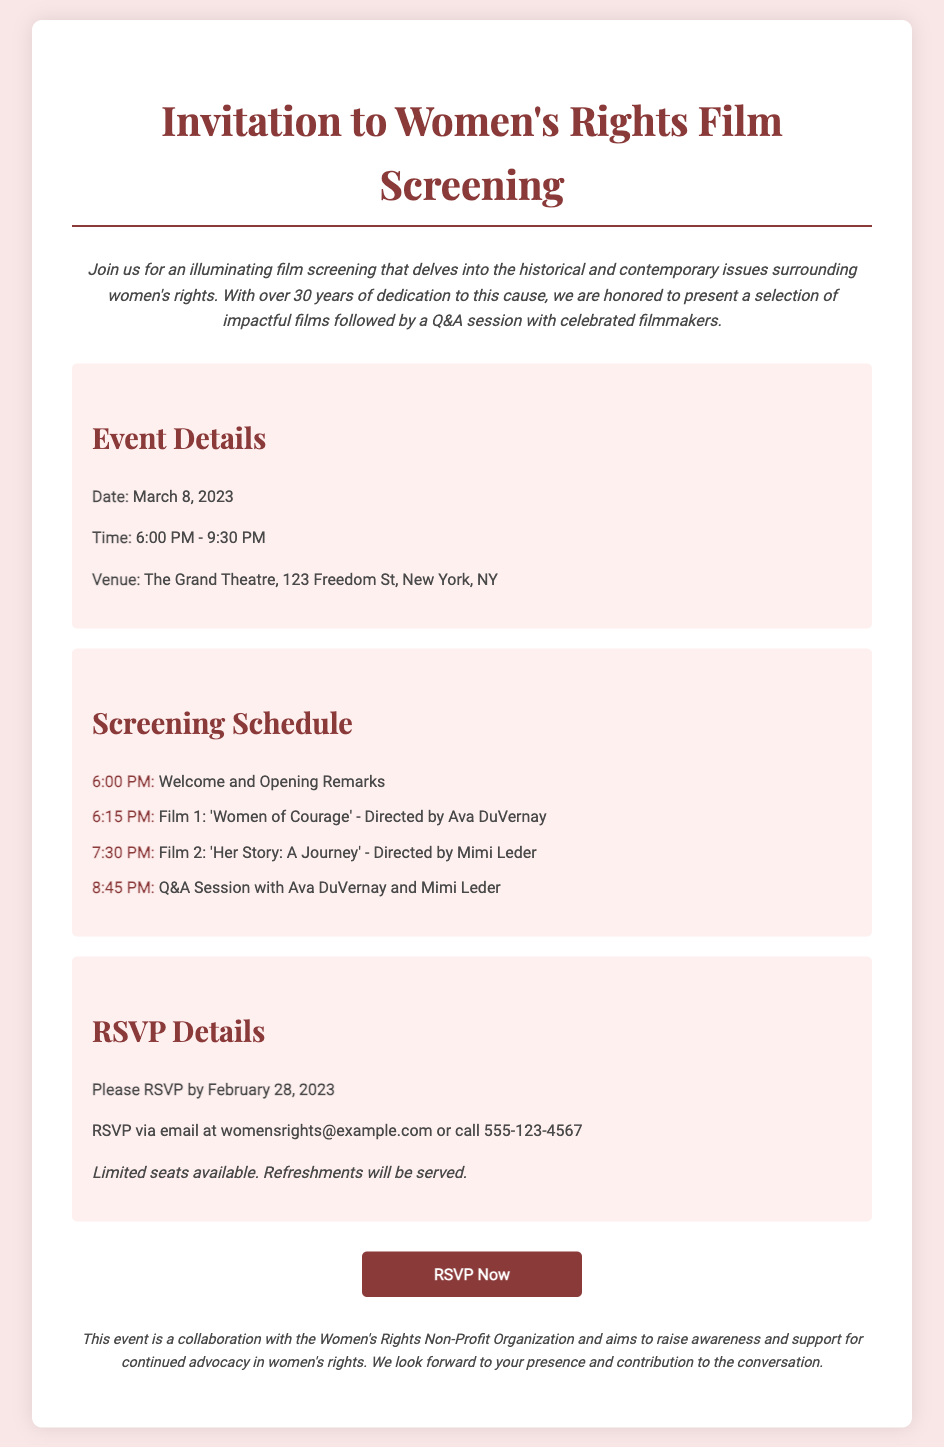What is the date of the event? The date of the event is directly stated in the document under Event Details.
Answer: March 8, 2023 What time does the screening start? The start time is mentioned in the document as part of the Event Details section.
Answer: 6:00 PM Who directed the first film? The director of the first film is specifically mentioned in the Screening Schedule section.
Answer: Ava DuVernay What is the venue name? The venue name is provided in the Event Details section.
Answer: The Grand Theatre How long is the Q&A session scheduled to last? The Q&A session follows the screenings, and its timing can be determined by the schedule provided.
Answer: 15 minutes What is the RSVP deadline? The RSVP deadline is explicitly stated in the RSVP Details paragraph.
Answer: February 28, 2023 How can attendees RSVP? The RSVP methods are detailed in the RSVP Details section.
Answer: Email or call What type of organization is the event in collaboration with? The collaboration partner is mentioned in the additional notes at the bottom of the document.
Answer: Women's Rights Non-Profit Organization What refreshments will be served? While it states that refreshments will be served, specific types are not mentioned.
Answer: Refreshments 